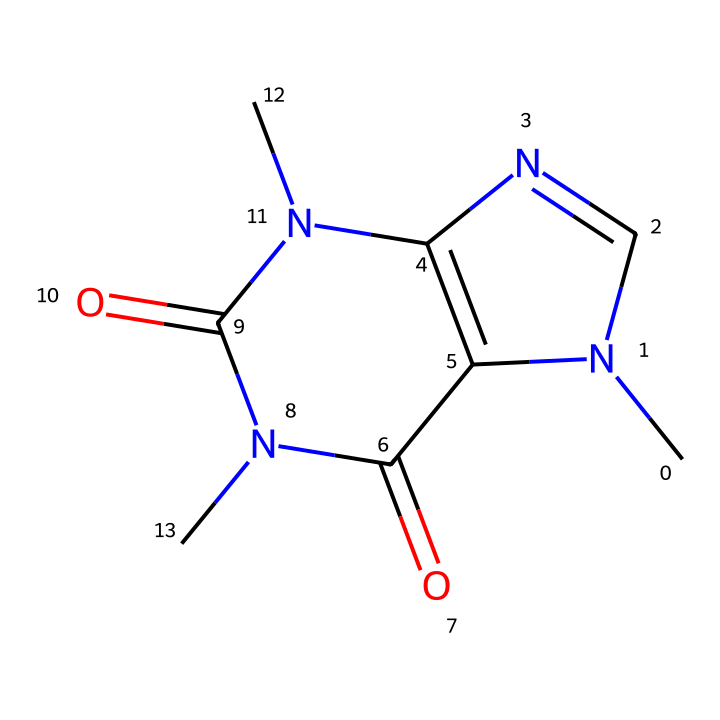What is the name of this chemical? The structure provided corresponds to caffeine, a well-known stimulant, which is commonly associated with enhancing alertness and athletic performance.
Answer: caffeine How many nitrogen atoms are in the structure? Upon analyzing the SMILES representation, we count three nitrogen atoms represented by ‘N’.
Answer: three What type of chemical is this compound classified as? This compound is classified as a xanthine alkaloid due to its structural features, including the presence of xanthine and nitrogen atoms.
Answer: xanthine alkaloid How many carbon atoms are present in the structure? By counting the carbon atoms represented in the SMILES, we identify eight carbon atoms in total.
Answer: eight What is the primary effect of caffeine on athletes? Caffeine primarily acts as a stimulant that increases alertness and reduces the perception of effort during physical activities.
Answer: stimulant What is the main reason caffeine is used in sports? Caffeine enhances endurance performance and improves reaction time, making it advantageous for athletes in various sports, especially during doubles tennis matches where quick reflexes are crucial.
Answer: endurance performance How does caffeine impact muscle performance? Caffeine may improve muscle contraction efficiency and help delay fatigue, thus potentially enhancing overall athletic performance during intense activities.
Answer: improves muscle contraction efficiency 